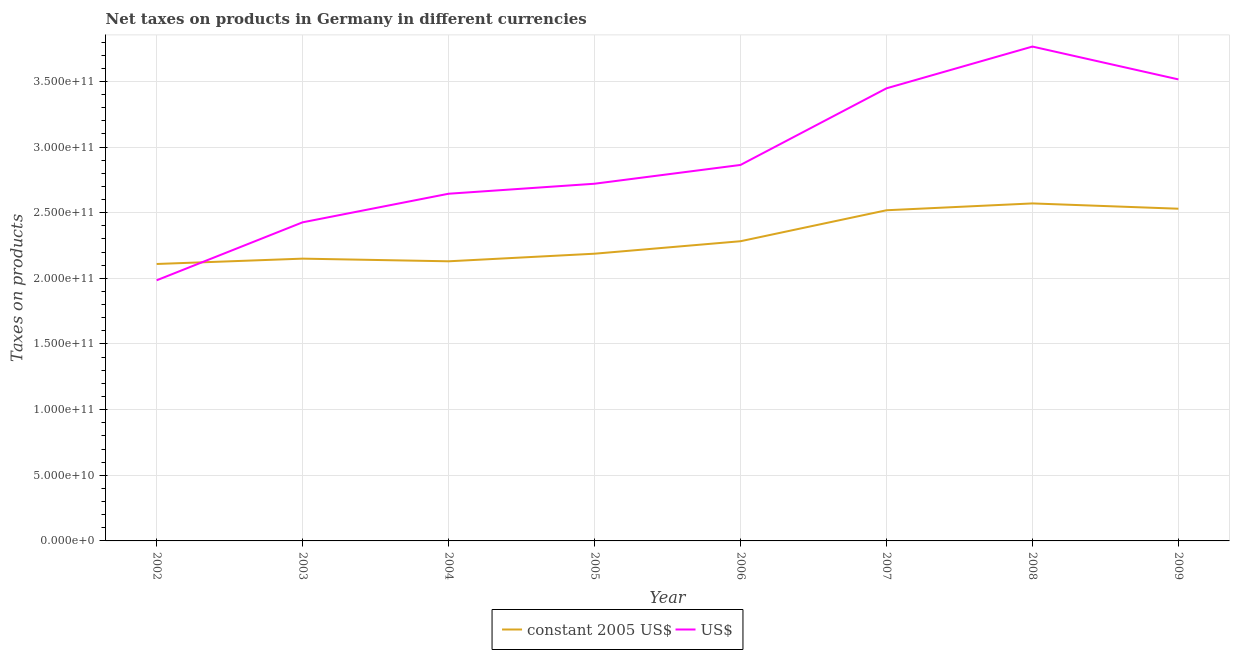How many different coloured lines are there?
Your response must be concise. 2. What is the net taxes in us$ in 2002?
Your response must be concise. 1.99e+11. Across all years, what is the maximum net taxes in us$?
Offer a terse response. 3.77e+11. Across all years, what is the minimum net taxes in constant 2005 us$?
Give a very brief answer. 2.11e+11. What is the total net taxes in constant 2005 us$ in the graph?
Your response must be concise. 1.85e+12. What is the difference between the net taxes in us$ in 2004 and that in 2006?
Give a very brief answer. -2.19e+1. What is the difference between the net taxes in us$ in 2006 and the net taxes in constant 2005 us$ in 2003?
Offer a very short reply. 7.14e+1. What is the average net taxes in constant 2005 us$ per year?
Your answer should be compact. 2.31e+11. In the year 2002, what is the difference between the net taxes in us$ and net taxes in constant 2005 us$?
Ensure brevity in your answer.  -1.24e+1. What is the ratio of the net taxes in constant 2005 us$ in 2002 to that in 2005?
Your answer should be very brief. 0.96. Is the net taxes in constant 2005 us$ in 2008 less than that in 2009?
Provide a short and direct response. No. What is the difference between the highest and the second highest net taxes in constant 2005 us$?
Keep it short and to the point. 4.03e+09. What is the difference between the highest and the lowest net taxes in constant 2005 us$?
Provide a succinct answer. 4.61e+1. In how many years, is the net taxes in constant 2005 us$ greater than the average net taxes in constant 2005 us$ taken over all years?
Offer a very short reply. 3. Is the sum of the net taxes in constant 2005 us$ in 2006 and 2008 greater than the maximum net taxes in us$ across all years?
Make the answer very short. Yes. How many lines are there?
Offer a terse response. 2. How many years are there in the graph?
Provide a succinct answer. 8. Are the values on the major ticks of Y-axis written in scientific E-notation?
Give a very brief answer. Yes. Where does the legend appear in the graph?
Your answer should be very brief. Bottom center. What is the title of the graph?
Ensure brevity in your answer.  Net taxes on products in Germany in different currencies. Does "Resident" appear as one of the legend labels in the graph?
Your answer should be very brief. No. What is the label or title of the Y-axis?
Keep it short and to the point. Taxes on products. What is the Taxes on products in constant 2005 US$ in 2002?
Provide a succinct answer. 2.11e+11. What is the Taxes on products in US$ in 2002?
Keep it short and to the point. 1.99e+11. What is the Taxes on products in constant 2005 US$ in 2003?
Your response must be concise. 2.15e+11. What is the Taxes on products of US$ in 2003?
Provide a succinct answer. 2.43e+11. What is the Taxes on products of constant 2005 US$ in 2004?
Give a very brief answer. 2.13e+11. What is the Taxes on products in US$ in 2004?
Your answer should be compact. 2.64e+11. What is the Taxes on products of constant 2005 US$ in 2005?
Offer a terse response. 2.19e+11. What is the Taxes on products of US$ in 2005?
Give a very brief answer. 2.72e+11. What is the Taxes on products of constant 2005 US$ in 2006?
Provide a short and direct response. 2.28e+11. What is the Taxes on products of US$ in 2006?
Provide a succinct answer. 2.86e+11. What is the Taxes on products in constant 2005 US$ in 2007?
Your answer should be compact. 2.52e+11. What is the Taxes on products of US$ in 2007?
Provide a short and direct response. 3.45e+11. What is the Taxes on products in constant 2005 US$ in 2008?
Provide a succinct answer. 2.57e+11. What is the Taxes on products in US$ in 2008?
Your answer should be compact. 3.77e+11. What is the Taxes on products of constant 2005 US$ in 2009?
Your answer should be compact. 2.53e+11. What is the Taxes on products of US$ in 2009?
Your answer should be compact. 3.52e+11. Across all years, what is the maximum Taxes on products of constant 2005 US$?
Ensure brevity in your answer.  2.57e+11. Across all years, what is the maximum Taxes on products in US$?
Your response must be concise. 3.77e+11. Across all years, what is the minimum Taxes on products in constant 2005 US$?
Offer a very short reply. 2.11e+11. Across all years, what is the minimum Taxes on products of US$?
Offer a very short reply. 1.99e+11. What is the total Taxes on products of constant 2005 US$ in the graph?
Keep it short and to the point. 1.85e+12. What is the total Taxes on products of US$ in the graph?
Your answer should be very brief. 2.34e+12. What is the difference between the Taxes on products in constant 2005 US$ in 2002 and that in 2003?
Offer a terse response. -4.07e+09. What is the difference between the Taxes on products of US$ in 2002 and that in 2003?
Give a very brief answer. -4.42e+1. What is the difference between the Taxes on products in constant 2005 US$ in 2002 and that in 2004?
Offer a very short reply. -2.05e+09. What is the difference between the Taxes on products in US$ in 2002 and that in 2004?
Offer a very short reply. -6.59e+1. What is the difference between the Taxes on products of constant 2005 US$ in 2002 and that in 2005?
Provide a succinct answer. -7.83e+09. What is the difference between the Taxes on products in US$ in 2002 and that in 2005?
Provide a short and direct response. -7.36e+1. What is the difference between the Taxes on products in constant 2005 US$ in 2002 and that in 2006?
Your answer should be compact. -1.73e+1. What is the difference between the Taxes on products in US$ in 2002 and that in 2006?
Make the answer very short. -8.79e+1. What is the difference between the Taxes on products in constant 2005 US$ in 2002 and that in 2007?
Provide a short and direct response. -4.09e+1. What is the difference between the Taxes on products of US$ in 2002 and that in 2007?
Your answer should be compact. -1.46e+11. What is the difference between the Taxes on products of constant 2005 US$ in 2002 and that in 2008?
Your answer should be compact. -4.61e+1. What is the difference between the Taxes on products of US$ in 2002 and that in 2008?
Offer a very short reply. -1.78e+11. What is the difference between the Taxes on products of constant 2005 US$ in 2002 and that in 2009?
Offer a very short reply. -4.21e+1. What is the difference between the Taxes on products in US$ in 2002 and that in 2009?
Keep it short and to the point. -1.53e+11. What is the difference between the Taxes on products in constant 2005 US$ in 2003 and that in 2004?
Keep it short and to the point. 2.02e+09. What is the difference between the Taxes on products in US$ in 2003 and that in 2004?
Offer a terse response. -2.18e+1. What is the difference between the Taxes on products of constant 2005 US$ in 2003 and that in 2005?
Your answer should be very brief. -3.76e+09. What is the difference between the Taxes on products in US$ in 2003 and that in 2005?
Offer a very short reply. -2.94e+1. What is the difference between the Taxes on products of constant 2005 US$ in 2003 and that in 2006?
Ensure brevity in your answer.  -1.33e+1. What is the difference between the Taxes on products in US$ in 2003 and that in 2006?
Ensure brevity in your answer.  -4.37e+1. What is the difference between the Taxes on products in constant 2005 US$ in 2003 and that in 2007?
Make the answer very short. -3.69e+1. What is the difference between the Taxes on products in US$ in 2003 and that in 2007?
Your answer should be compact. -1.02e+11. What is the difference between the Taxes on products in constant 2005 US$ in 2003 and that in 2008?
Give a very brief answer. -4.21e+1. What is the difference between the Taxes on products of US$ in 2003 and that in 2008?
Your answer should be compact. -1.34e+11. What is the difference between the Taxes on products of constant 2005 US$ in 2003 and that in 2009?
Provide a succinct answer. -3.80e+1. What is the difference between the Taxes on products in US$ in 2003 and that in 2009?
Keep it short and to the point. -1.09e+11. What is the difference between the Taxes on products in constant 2005 US$ in 2004 and that in 2005?
Offer a terse response. -5.78e+09. What is the difference between the Taxes on products in US$ in 2004 and that in 2005?
Your answer should be very brief. -7.62e+09. What is the difference between the Taxes on products in constant 2005 US$ in 2004 and that in 2006?
Provide a short and direct response. -1.53e+1. What is the difference between the Taxes on products in US$ in 2004 and that in 2006?
Offer a terse response. -2.19e+1. What is the difference between the Taxes on products in constant 2005 US$ in 2004 and that in 2007?
Keep it short and to the point. -3.89e+1. What is the difference between the Taxes on products of US$ in 2004 and that in 2007?
Keep it short and to the point. -8.03e+1. What is the difference between the Taxes on products in constant 2005 US$ in 2004 and that in 2008?
Your response must be concise. -4.41e+1. What is the difference between the Taxes on products in US$ in 2004 and that in 2008?
Your answer should be very brief. -1.12e+11. What is the difference between the Taxes on products in constant 2005 US$ in 2004 and that in 2009?
Keep it short and to the point. -4.00e+1. What is the difference between the Taxes on products in US$ in 2004 and that in 2009?
Your response must be concise. -8.71e+1. What is the difference between the Taxes on products of constant 2005 US$ in 2005 and that in 2006?
Offer a terse response. -9.50e+09. What is the difference between the Taxes on products of US$ in 2005 and that in 2006?
Offer a terse response. -1.43e+1. What is the difference between the Taxes on products in constant 2005 US$ in 2005 and that in 2007?
Your response must be concise. -3.31e+1. What is the difference between the Taxes on products of US$ in 2005 and that in 2007?
Make the answer very short. -7.27e+1. What is the difference between the Taxes on products of constant 2005 US$ in 2005 and that in 2008?
Make the answer very short. -3.83e+1. What is the difference between the Taxes on products in US$ in 2005 and that in 2008?
Make the answer very short. -1.04e+11. What is the difference between the Taxes on products of constant 2005 US$ in 2005 and that in 2009?
Give a very brief answer. -3.43e+1. What is the difference between the Taxes on products of US$ in 2005 and that in 2009?
Provide a succinct answer. -7.95e+1. What is the difference between the Taxes on products in constant 2005 US$ in 2006 and that in 2007?
Offer a very short reply. -2.36e+1. What is the difference between the Taxes on products of US$ in 2006 and that in 2007?
Your answer should be very brief. -5.84e+1. What is the difference between the Taxes on products of constant 2005 US$ in 2006 and that in 2008?
Make the answer very short. -2.88e+1. What is the difference between the Taxes on products in US$ in 2006 and that in 2008?
Give a very brief answer. -9.02e+1. What is the difference between the Taxes on products in constant 2005 US$ in 2006 and that in 2009?
Provide a succinct answer. -2.48e+1. What is the difference between the Taxes on products in US$ in 2006 and that in 2009?
Your answer should be compact. -6.52e+1. What is the difference between the Taxes on products of constant 2005 US$ in 2007 and that in 2008?
Offer a very short reply. -5.20e+09. What is the difference between the Taxes on products in US$ in 2007 and that in 2008?
Make the answer very short. -3.18e+1. What is the difference between the Taxes on products of constant 2005 US$ in 2007 and that in 2009?
Ensure brevity in your answer.  -1.17e+09. What is the difference between the Taxes on products in US$ in 2007 and that in 2009?
Keep it short and to the point. -6.80e+09. What is the difference between the Taxes on products in constant 2005 US$ in 2008 and that in 2009?
Offer a very short reply. 4.03e+09. What is the difference between the Taxes on products in US$ in 2008 and that in 2009?
Provide a succinct answer. 2.50e+1. What is the difference between the Taxes on products of constant 2005 US$ in 2002 and the Taxes on products of US$ in 2003?
Make the answer very short. -3.17e+1. What is the difference between the Taxes on products of constant 2005 US$ in 2002 and the Taxes on products of US$ in 2004?
Provide a succinct answer. -5.35e+1. What is the difference between the Taxes on products of constant 2005 US$ in 2002 and the Taxes on products of US$ in 2005?
Keep it short and to the point. -6.11e+1. What is the difference between the Taxes on products of constant 2005 US$ in 2002 and the Taxes on products of US$ in 2006?
Provide a succinct answer. -7.54e+1. What is the difference between the Taxes on products in constant 2005 US$ in 2002 and the Taxes on products in US$ in 2007?
Make the answer very short. -1.34e+11. What is the difference between the Taxes on products of constant 2005 US$ in 2002 and the Taxes on products of US$ in 2008?
Keep it short and to the point. -1.66e+11. What is the difference between the Taxes on products of constant 2005 US$ in 2002 and the Taxes on products of US$ in 2009?
Provide a succinct answer. -1.41e+11. What is the difference between the Taxes on products of constant 2005 US$ in 2003 and the Taxes on products of US$ in 2004?
Your answer should be compact. -4.94e+1. What is the difference between the Taxes on products in constant 2005 US$ in 2003 and the Taxes on products in US$ in 2005?
Offer a very short reply. -5.71e+1. What is the difference between the Taxes on products of constant 2005 US$ in 2003 and the Taxes on products of US$ in 2006?
Keep it short and to the point. -7.14e+1. What is the difference between the Taxes on products of constant 2005 US$ in 2003 and the Taxes on products of US$ in 2007?
Ensure brevity in your answer.  -1.30e+11. What is the difference between the Taxes on products of constant 2005 US$ in 2003 and the Taxes on products of US$ in 2008?
Provide a succinct answer. -1.62e+11. What is the difference between the Taxes on products of constant 2005 US$ in 2003 and the Taxes on products of US$ in 2009?
Keep it short and to the point. -1.37e+11. What is the difference between the Taxes on products in constant 2005 US$ in 2004 and the Taxes on products in US$ in 2005?
Give a very brief answer. -5.91e+1. What is the difference between the Taxes on products of constant 2005 US$ in 2004 and the Taxes on products of US$ in 2006?
Your response must be concise. -7.34e+1. What is the difference between the Taxes on products of constant 2005 US$ in 2004 and the Taxes on products of US$ in 2007?
Offer a terse response. -1.32e+11. What is the difference between the Taxes on products of constant 2005 US$ in 2004 and the Taxes on products of US$ in 2008?
Make the answer very short. -1.64e+11. What is the difference between the Taxes on products of constant 2005 US$ in 2004 and the Taxes on products of US$ in 2009?
Give a very brief answer. -1.39e+11. What is the difference between the Taxes on products of constant 2005 US$ in 2005 and the Taxes on products of US$ in 2006?
Provide a short and direct response. -6.76e+1. What is the difference between the Taxes on products in constant 2005 US$ in 2005 and the Taxes on products in US$ in 2007?
Make the answer very short. -1.26e+11. What is the difference between the Taxes on products of constant 2005 US$ in 2005 and the Taxes on products of US$ in 2008?
Ensure brevity in your answer.  -1.58e+11. What is the difference between the Taxes on products of constant 2005 US$ in 2005 and the Taxes on products of US$ in 2009?
Your answer should be compact. -1.33e+11. What is the difference between the Taxes on products in constant 2005 US$ in 2006 and the Taxes on products in US$ in 2007?
Provide a short and direct response. -1.16e+11. What is the difference between the Taxes on products in constant 2005 US$ in 2006 and the Taxes on products in US$ in 2008?
Ensure brevity in your answer.  -1.48e+11. What is the difference between the Taxes on products in constant 2005 US$ in 2006 and the Taxes on products in US$ in 2009?
Your response must be concise. -1.23e+11. What is the difference between the Taxes on products of constant 2005 US$ in 2007 and the Taxes on products of US$ in 2008?
Provide a succinct answer. -1.25e+11. What is the difference between the Taxes on products of constant 2005 US$ in 2007 and the Taxes on products of US$ in 2009?
Ensure brevity in your answer.  -9.97e+1. What is the difference between the Taxes on products in constant 2005 US$ in 2008 and the Taxes on products in US$ in 2009?
Keep it short and to the point. -9.45e+1. What is the average Taxes on products of constant 2005 US$ per year?
Make the answer very short. 2.31e+11. What is the average Taxes on products of US$ per year?
Keep it short and to the point. 2.92e+11. In the year 2002, what is the difference between the Taxes on products in constant 2005 US$ and Taxes on products in US$?
Give a very brief answer. 1.24e+1. In the year 2003, what is the difference between the Taxes on products of constant 2005 US$ and Taxes on products of US$?
Offer a very short reply. -2.77e+1. In the year 2004, what is the difference between the Taxes on products of constant 2005 US$ and Taxes on products of US$?
Provide a succinct answer. -5.15e+1. In the year 2005, what is the difference between the Taxes on products in constant 2005 US$ and Taxes on products in US$?
Your answer should be very brief. -5.33e+1. In the year 2006, what is the difference between the Taxes on products of constant 2005 US$ and Taxes on products of US$?
Provide a short and direct response. -5.81e+1. In the year 2007, what is the difference between the Taxes on products of constant 2005 US$ and Taxes on products of US$?
Your response must be concise. -9.29e+1. In the year 2008, what is the difference between the Taxes on products of constant 2005 US$ and Taxes on products of US$?
Provide a short and direct response. -1.19e+11. In the year 2009, what is the difference between the Taxes on products in constant 2005 US$ and Taxes on products in US$?
Provide a short and direct response. -9.85e+1. What is the ratio of the Taxes on products in constant 2005 US$ in 2002 to that in 2003?
Keep it short and to the point. 0.98. What is the ratio of the Taxes on products in US$ in 2002 to that in 2003?
Give a very brief answer. 0.82. What is the ratio of the Taxes on products in US$ in 2002 to that in 2004?
Your answer should be very brief. 0.75. What is the ratio of the Taxes on products in constant 2005 US$ in 2002 to that in 2005?
Offer a very short reply. 0.96. What is the ratio of the Taxes on products in US$ in 2002 to that in 2005?
Give a very brief answer. 0.73. What is the ratio of the Taxes on products in constant 2005 US$ in 2002 to that in 2006?
Provide a succinct answer. 0.92. What is the ratio of the Taxes on products of US$ in 2002 to that in 2006?
Offer a terse response. 0.69. What is the ratio of the Taxes on products in constant 2005 US$ in 2002 to that in 2007?
Ensure brevity in your answer.  0.84. What is the ratio of the Taxes on products in US$ in 2002 to that in 2007?
Offer a very short reply. 0.58. What is the ratio of the Taxes on products in constant 2005 US$ in 2002 to that in 2008?
Give a very brief answer. 0.82. What is the ratio of the Taxes on products of US$ in 2002 to that in 2008?
Your answer should be very brief. 0.53. What is the ratio of the Taxes on products in constant 2005 US$ in 2002 to that in 2009?
Offer a terse response. 0.83. What is the ratio of the Taxes on products of US$ in 2002 to that in 2009?
Ensure brevity in your answer.  0.56. What is the ratio of the Taxes on products of constant 2005 US$ in 2003 to that in 2004?
Offer a terse response. 1.01. What is the ratio of the Taxes on products in US$ in 2003 to that in 2004?
Offer a terse response. 0.92. What is the ratio of the Taxes on products in constant 2005 US$ in 2003 to that in 2005?
Make the answer very short. 0.98. What is the ratio of the Taxes on products in US$ in 2003 to that in 2005?
Provide a succinct answer. 0.89. What is the ratio of the Taxes on products in constant 2005 US$ in 2003 to that in 2006?
Your answer should be very brief. 0.94. What is the ratio of the Taxes on products in US$ in 2003 to that in 2006?
Offer a terse response. 0.85. What is the ratio of the Taxes on products in constant 2005 US$ in 2003 to that in 2007?
Make the answer very short. 0.85. What is the ratio of the Taxes on products of US$ in 2003 to that in 2007?
Provide a short and direct response. 0.7. What is the ratio of the Taxes on products of constant 2005 US$ in 2003 to that in 2008?
Your response must be concise. 0.84. What is the ratio of the Taxes on products in US$ in 2003 to that in 2008?
Offer a terse response. 0.64. What is the ratio of the Taxes on products in constant 2005 US$ in 2003 to that in 2009?
Keep it short and to the point. 0.85. What is the ratio of the Taxes on products in US$ in 2003 to that in 2009?
Keep it short and to the point. 0.69. What is the ratio of the Taxes on products of constant 2005 US$ in 2004 to that in 2005?
Offer a very short reply. 0.97. What is the ratio of the Taxes on products of constant 2005 US$ in 2004 to that in 2006?
Your response must be concise. 0.93. What is the ratio of the Taxes on products of US$ in 2004 to that in 2006?
Provide a short and direct response. 0.92. What is the ratio of the Taxes on products of constant 2005 US$ in 2004 to that in 2007?
Provide a short and direct response. 0.85. What is the ratio of the Taxes on products of US$ in 2004 to that in 2007?
Ensure brevity in your answer.  0.77. What is the ratio of the Taxes on products of constant 2005 US$ in 2004 to that in 2008?
Your answer should be compact. 0.83. What is the ratio of the Taxes on products in US$ in 2004 to that in 2008?
Ensure brevity in your answer.  0.7. What is the ratio of the Taxes on products of constant 2005 US$ in 2004 to that in 2009?
Offer a terse response. 0.84. What is the ratio of the Taxes on products of US$ in 2004 to that in 2009?
Make the answer very short. 0.75. What is the ratio of the Taxes on products in constant 2005 US$ in 2005 to that in 2006?
Ensure brevity in your answer.  0.96. What is the ratio of the Taxes on products in US$ in 2005 to that in 2006?
Your answer should be compact. 0.95. What is the ratio of the Taxes on products in constant 2005 US$ in 2005 to that in 2007?
Offer a terse response. 0.87. What is the ratio of the Taxes on products of US$ in 2005 to that in 2007?
Offer a very short reply. 0.79. What is the ratio of the Taxes on products of constant 2005 US$ in 2005 to that in 2008?
Keep it short and to the point. 0.85. What is the ratio of the Taxes on products of US$ in 2005 to that in 2008?
Your answer should be compact. 0.72. What is the ratio of the Taxes on products of constant 2005 US$ in 2005 to that in 2009?
Your response must be concise. 0.86. What is the ratio of the Taxes on products in US$ in 2005 to that in 2009?
Ensure brevity in your answer.  0.77. What is the ratio of the Taxes on products of constant 2005 US$ in 2006 to that in 2007?
Your answer should be very brief. 0.91. What is the ratio of the Taxes on products of US$ in 2006 to that in 2007?
Your answer should be very brief. 0.83. What is the ratio of the Taxes on products of constant 2005 US$ in 2006 to that in 2008?
Provide a succinct answer. 0.89. What is the ratio of the Taxes on products of US$ in 2006 to that in 2008?
Keep it short and to the point. 0.76. What is the ratio of the Taxes on products of constant 2005 US$ in 2006 to that in 2009?
Your answer should be compact. 0.9. What is the ratio of the Taxes on products of US$ in 2006 to that in 2009?
Offer a very short reply. 0.81. What is the ratio of the Taxes on products of constant 2005 US$ in 2007 to that in 2008?
Provide a short and direct response. 0.98. What is the ratio of the Taxes on products in US$ in 2007 to that in 2008?
Give a very brief answer. 0.92. What is the ratio of the Taxes on products of US$ in 2007 to that in 2009?
Your response must be concise. 0.98. What is the ratio of the Taxes on products in constant 2005 US$ in 2008 to that in 2009?
Provide a short and direct response. 1.02. What is the ratio of the Taxes on products in US$ in 2008 to that in 2009?
Your answer should be very brief. 1.07. What is the difference between the highest and the second highest Taxes on products of constant 2005 US$?
Your answer should be very brief. 4.03e+09. What is the difference between the highest and the second highest Taxes on products in US$?
Keep it short and to the point. 2.50e+1. What is the difference between the highest and the lowest Taxes on products of constant 2005 US$?
Make the answer very short. 4.61e+1. What is the difference between the highest and the lowest Taxes on products of US$?
Provide a succinct answer. 1.78e+11. 